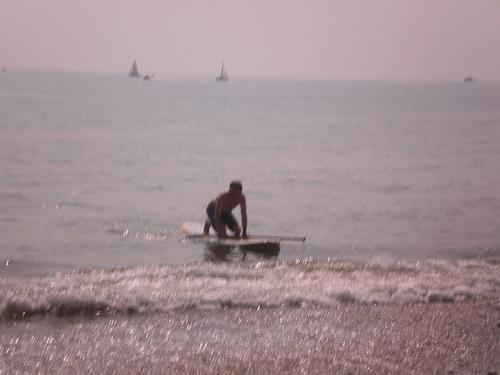Mention the primary activity occurring in the image and the conditions of the environment. A man is paddleboarding near the shore on a calm and sunny day, with a few sailboats visible in the distance. Tell a brief story about the main subject of the image. On a peaceful morning, a man decides to embrace the tranquility of the sea by paddleboarding. As he glides gently along the shimmering waters, he feels a deep connection with nature, enjoying the serene environment and the gentle lapping of the waves. Describe the main subject in the image using creative adjectives. A serene and focused paddleboarder smoothly navigates the calm sea, his figure silhouetted against the sparkling water under the bright sun. Express the main action of the image and how the subject is handling it. A man is skillfully balancing on a paddleboard, smoothly navigating the gentle waves near the shore. Summarize the primary action taking place in the image. A man is paddleboarding close to the shore, enjoying the calm sea and sunny weather. In one sentence, describe the primary scene displayed in the image. A man paddleboards in calm waters near the shore, under a clear sky with distant sailboats. Use vivid and descriptive language to describe the main subject in the image. An adept paddleboarder, silhouetted against the shimmering sea, gracefully balances on his board, embracing the serene maritime atmosphere. Briefly discuss the focal point of the image using colorful language. Against a backdrop of a sparkling sea and distant sailboats, a solitary paddleboarder finds harmony with the ocean, effortlessly gliding along the water's surface. Provide an imaginative description of the main subject of the image. A lone explorer of the sea balances atop his paddleboard, merging with the rhythm of the gentle waves, as he moves silently along the coast. Provide a brief description of the main focus of the image. The image captures a man paddleboarding near the shore, enjoying the calm and sunny conditions of the sea. 